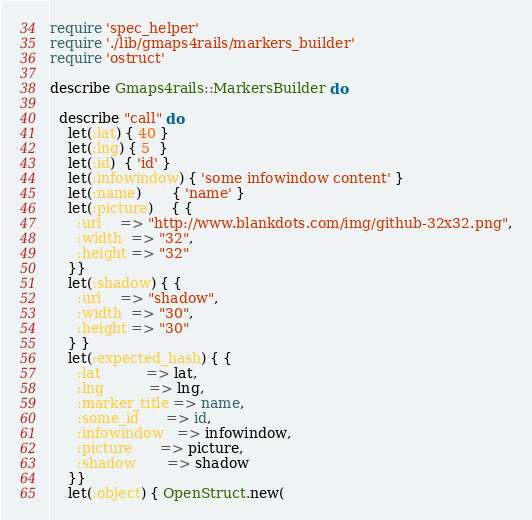Convert code to text. <code><loc_0><loc_0><loc_500><loc_500><_Ruby_>require 'spec_helper'
require './lib/gmaps4rails/markers_builder'
require 'ostruct'

describe Gmaps4rails::MarkersBuilder do

  describe "call" do
    let(:lat) { 40 }
    let(:lng) { 5  }
    let(:id)  { 'id' }
    let(:infowindow) { 'some infowindow content' }
    let(:name)       { 'name' }
    let(:picture)    { {
      :url    => "http://www.blankdots.com/img/github-32x32.png",
      :width  => "32",
      :height => "32"
    }}
    let(:shadow) { {
      :url    => "shadow",
      :width  => "30",
      :height => "30"
    } }
    let(:expected_hash) { {
      :lat          => lat,
      :lng          => lng,
      :marker_title => name,
      :some_id      => id,
      :infowindow   => infowindow,
      :picture      => picture,
      :shadow       => shadow
    }}
    let(:object) { OpenStruct.new(</code> 